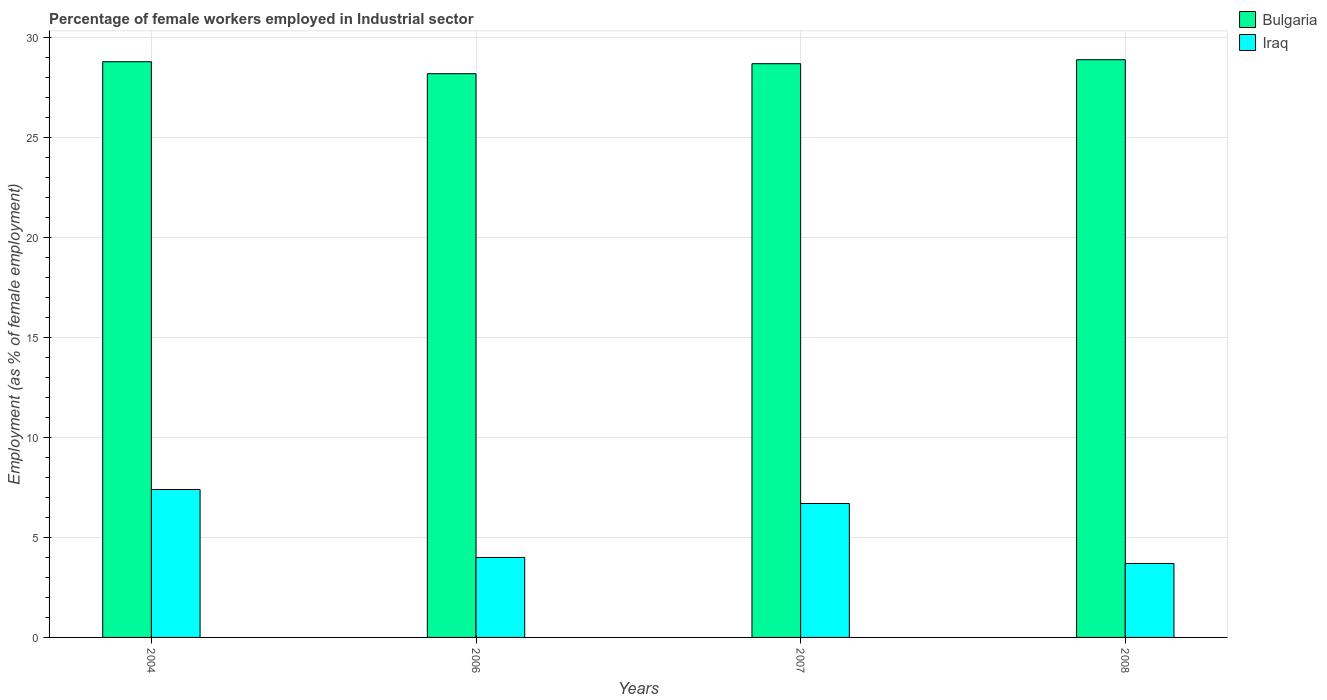How many different coloured bars are there?
Your answer should be compact. 2. How many groups of bars are there?
Your answer should be compact. 4. Are the number of bars per tick equal to the number of legend labels?
Provide a short and direct response. Yes. How many bars are there on the 1st tick from the right?
Your answer should be very brief. 2. What is the label of the 3rd group of bars from the left?
Make the answer very short. 2007. Across all years, what is the maximum percentage of females employed in Industrial sector in Iraq?
Give a very brief answer. 7.4. Across all years, what is the minimum percentage of females employed in Industrial sector in Iraq?
Offer a terse response. 3.7. What is the total percentage of females employed in Industrial sector in Bulgaria in the graph?
Offer a terse response. 114.6. What is the difference between the percentage of females employed in Industrial sector in Iraq in 2004 and that in 2007?
Ensure brevity in your answer.  0.7. What is the difference between the percentage of females employed in Industrial sector in Iraq in 2008 and the percentage of females employed in Industrial sector in Bulgaria in 2006?
Your answer should be compact. -24.5. What is the average percentage of females employed in Industrial sector in Bulgaria per year?
Provide a succinct answer. 28.65. In the year 2004, what is the difference between the percentage of females employed in Industrial sector in Iraq and percentage of females employed in Industrial sector in Bulgaria?
Your answer should be very brief. -21.4. In how many years, is the percentage of females employed in Industrial sector in Iraq greater than 17 %?
Ensure brevity in your answer.  0. What is the ratio of the percentage of females employed in Industrial sector in Bulgaria in 2007 to that in 2008?
Make the answer very short. 0.99. Is the percentage of females employed in Industrial sector in Bulgaria in 2004 less than that in 2006?
Ensure brevity in your answer.  No. What is the difference between the highest and the second highest percentage of females employed in Industrial sector in Bulgaria?
Offer a very short reply. 0.1. What is the difference between the highest and the lowest percentage of females employed in Industrial sector in Iraq?
Offer a terse response. 3.7. What does the 1st bar from the right in 2008 represents?
Offer a terse response. Iraq. How many bars are there?
Provide a succinct answer. 8. Are all the bars in the graph horizontal?
Offer a very short reply. No. How many years are there in the graph?
Ensure brevity in your answer.  4. What is the difference between two consecutive major ticks on the Y-axis?
Offer a terse response. 5. Are the values on the major ticks of Y-axis written in scientific E-notation?
Provide a succinct answer. No. Does the graph contain grids?
Offer a very short reply. Yes. Where does the legend appear in the graph?
Provide a short and direct response. Top right. How are the legend labels stacked?
Ensure brevity in your answer.  Vertical. What is the title of the graph?
Give a very brief answer. Percentage of female workers employed in Industrial sector. What is the label or title of the Y-axis?
Provide a succinct answer. Employment (as % of female employment). What is the Employment (as % of female employment) of Bulgaria in 2004?
Keep it short and to the point. 28.8. What is the Employment (as % of female employment) of Iraq in 2004?
Make the answer very short. 7.4. What is the Employment (as % of female employment) of Bulgaria in 2006?
Give a very brief answer. 28.2. What is the Employment (as % of female employment) in Bulgaria in 2007?
Your answer should be very brief. 28.7. What is the Employment (as % of female employment) in Iraq in 2007?
Ensure brevity in your answer.  6.7. What is the Employment (as % of female employment) in Bulgaria in 2008?
Give a very brief answer. 28.9. What is the Employment (as % of female employment) in Iraq in 2008?
Offer a very short reply. 3.7. Across all years, what is the maximum Employment (as % of female employment) in Bulgaria?
Your response must be concise. 28.9. Across all years, what is the maximum Employment (as % of female employment) of Iraq?
Your answer should be very brief. 7.4. Across all years, what is the minimum Employment (as % of female employment) in Bulgaria?
Provide a succinct answer. 28.2. Across all years, what is the minimum Employment (as % of female employment) of Iraq?
Make the answer very short. 3.7. What is the total Employment (as % of female employment) of Bulgaria in the graph?
Ensure brevity in your answer.  114.6. What is the total Employment (as % of female employment) in Iraq in the graph?
Ensure brevity in your answer.  21.8. What is the difference between the Employment (as % of female employment) in Bulgaria in 2004 and that in 2007?
Your answer should be very brief. 0.1. What is the difference between the Employment (as % of female employment) of Iraq in 2004 and that in 2007?
Make the answer very short. 0.7. What is the difference between the Employment (as % of female employment) in Bulgaria in 2004 and that in 2008?
Make the answer very short. -0.1. What is the difference between the Employment (as % of female employment) in Iraq in 2004 and that in 2008?
Offer a very short reply. 3.7. What is the difference between the Employment (as % of female employment) in Iraq in 2006 and that in 2007?
Make the answer very short. -2.7. What is the difference between the Employment (as % of female employment) in Bulgaria in 2006 and that in 2008?
Keep it short and to the point. -0.7. What is the difference between the Employment (as % of female employment) of Iraq in 2007 and that in 2008?
Ensure brevity in your answer.  3. What is the difference between the Employment (as % of female employment) of Bulgaria in 2004 and the Employment (as % of female employment) of Iraq in 2006?
Offer a very short reply. 24.8. What is the difference between the Employment (as % of female employment) in Bulgaria in 2004 and the Employment (as % of female employment) in Iraq in 2007?
Ensure brevity in your answer.  22.1. What is the difference between the Employment (as % of female employment) in Bulgaria in 2004 and the Employment (as % of female employment) in Iraq in 2008?
Provide a succinct answer. 25.1. What is the difference between the Employment (as % of female employment) of Bulgaria in 2006 and the Employment (as % of female employment) of Iraq in 2008?
Keep it short and to the point. 24.5. What is the average Employment (as % of female employment) of Bulgaria per year?
Keep it short and to the point. 28.65. What is the average Employment (as % of female employment) in Iraq per year?
Offer a terse response. 5.45. In the year 2004, what is the difference between the Employment (as % of female employment) of Bulgaria and Employment (as % of female employment) of Iraq?
Your response must be concise. 21.4. In the year 2006, what is the difference between the Employment (as % of female employment) of Bulgaria and Employment (as % of female employment) of Iraq?
Provide a succinct answer. 24.2. In the year 2008, what is the difference between the Employment (as % of female employment) of Bulgaria and Employment (as % of female employment) of Iraq?
Keep it short and to the point. 25.2. What is the ratio of the Employment (as % of female employment) in Bulgaria in 2004 to that in 2006?
Your response must be concise. 1.02. What is the ratio of the Employment (as % of female employment) in Iraq in 2004 to that in 2006?
Offer a very short reply. 1.85. What is the ratio of the Employment (as % of female employment) of Bulgaria in 2004 to that in 2007?
Offer a terse response. 1. What is the ratio of the Employment (as % of female employment) of Iraq in 2004 to that in 2007?
Provide a short and direct response. 1.1. What is the ratio of the Employment (as % of female employment) of Bulgaria in 2004 to that in 2008?
Your answer should be very brief. 1. What is the ratio of the Employment (as % of female employment) in Bulgaria in 2006 to that in 2007?
Your answer should be compact. 0.98. What is the ratio of the Employment (as % of female employment) of Iraq in 2006 to that in 2007?
Your answer should be very brief. 0.6. What is the ratio of the Employment (as % of female employment) of Bulgaria in 2006 to that in 2008?
Your answer should be compact. 0.98. What is the ratio of the Employment (as % of female employment) of Iraq in 2006 to that in 2008?
Your response must be concise. 1.08. What is the ratio of the Employment (as % of female employment) of Bulgaria in 2007 to that in 2008?
Provide a short and direct response. 0.99. What is the ratio of the Employment (as % of female employment) in Iraq in 2007 to that in 2008?
Give a very brief answer. 1.81. What is the difference between the highest and the lowest Employment (as % of female employment) in Iraq?
Keep it short and to the point. 3.7. 